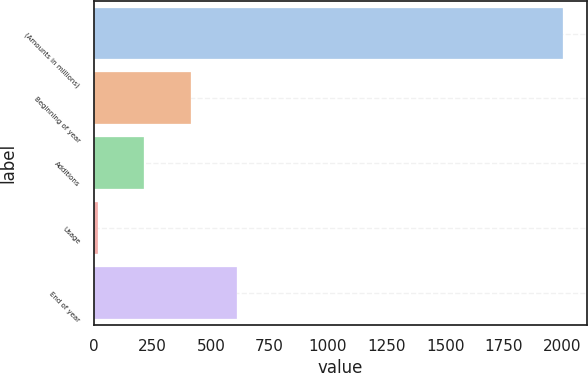<chart> <loc_0><loc_0><loc_500><loc_500><bar_chart><fcel>(Amounts in millions)<fcel>Beginning of year<fcel>Additions<fcel>Usage<fcel>End of year<nl><fcel>2006<fcel>413.2<fcel>214.1<fcel>15<fcel>612.3<nl></chart> 